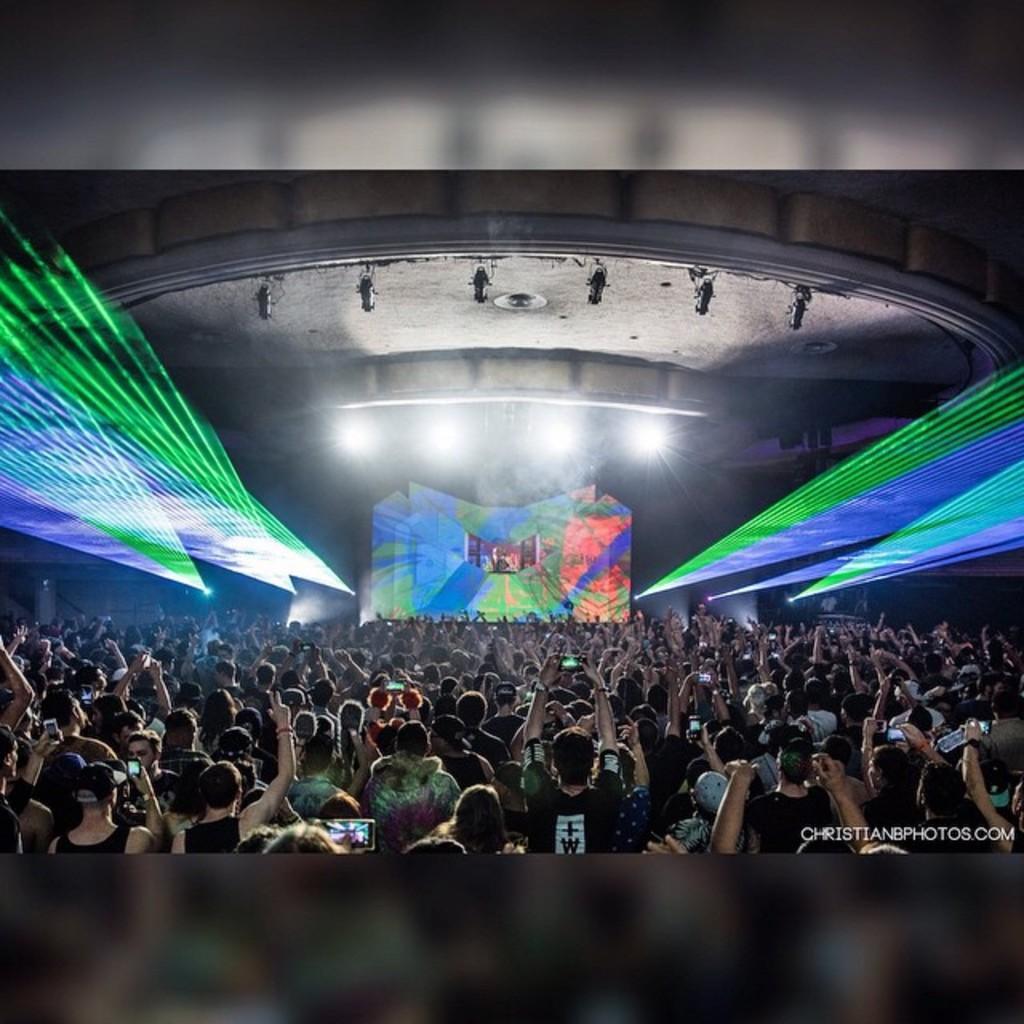In one or two sentences, can you explain what this image depicts? At the bottom of the image we can see a group of people are standing and some of them are holding mobiles. In the center of the image we can see screen lights are there. At the top of the image we can a roof. 